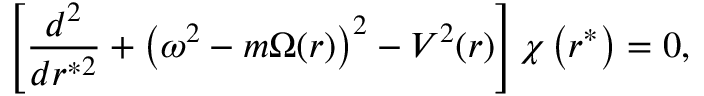Convert formula to latex. <formula><loc_0><loc_0><loc_500><loc_500>\left [ \frac { d ^ { 2 } } { d r ^ { * 2 } } + \left ( \omega ^ { 2 } - m \Omega ( r ) \right ) ^ { 2 } - V ^ { 2 } ( r ) \right ] \chi \left ( r ^ { * } \right ) = 0 ,</formula> 